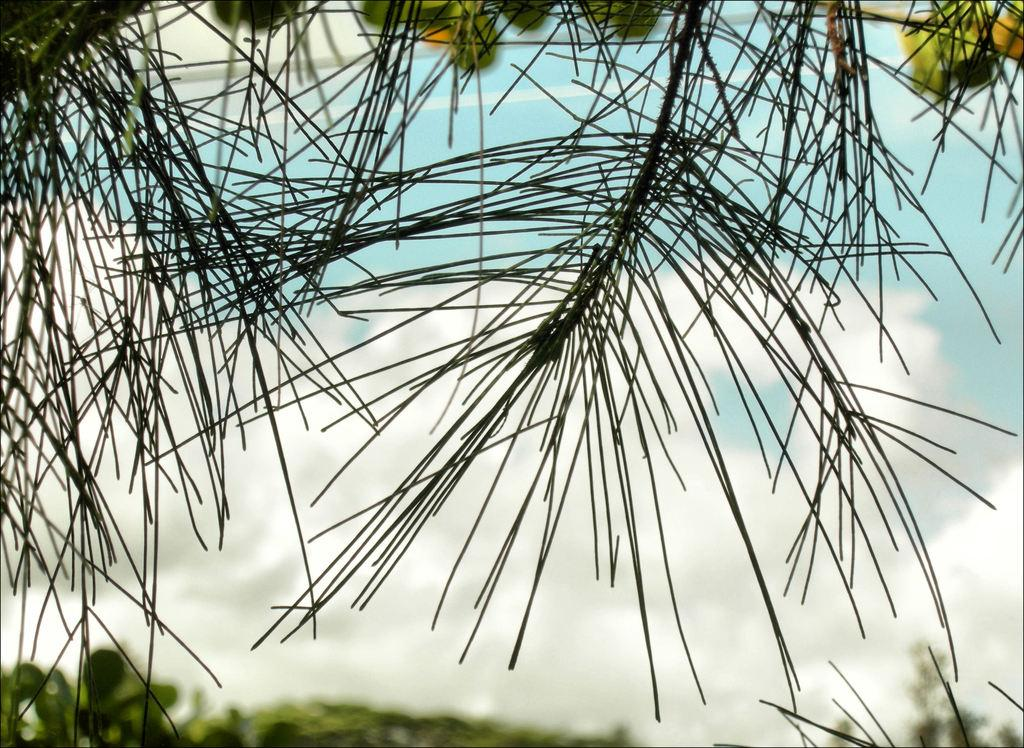What is in the foreground of the picture? There are branches of a tree in the foreground of the picture. What can be seen in the background of the image? The background of the image is blurred. What type of cabbage can be seen in the argument between the eggs in the image? There is no cabbage, argument, or eggs present in the image. 